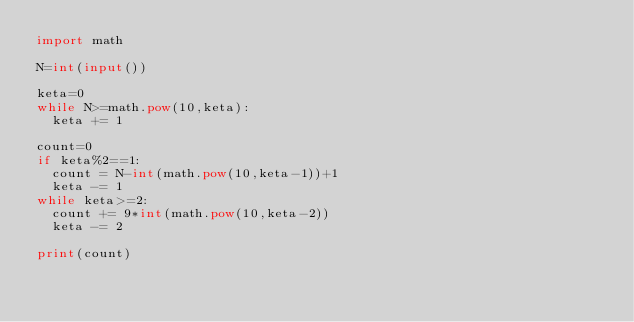Convert code to text. <code><loc_0><loc_0><loc_500><loc_500><_Python_>import math

N=int(input())

keta=0
while N>=math.pow(10,keta):
	keta += 1

count=0
if keta%2==1:
	count = N-int(math.pow(10,keta-1))+1
	keta -= 1
while keta>=2:
	count += 9*int(math.pow(10,keta-2))
	keta -= 2

print(count)</code> 